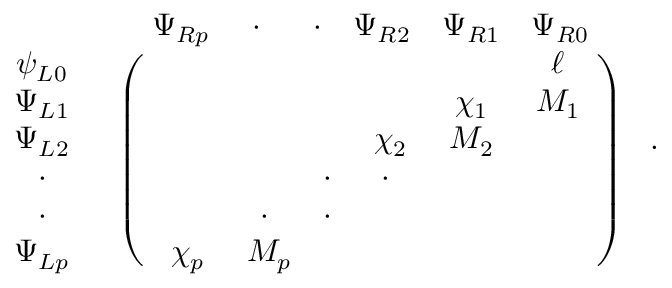Convert formula to latex. <formula><loc_0><loc_0><loc_500><loc_500>\begin{array} { c c & { { \begin{array} { c c c c c c } { { \Psi _ { R p } } } & { \cdot } & { \cdot } & { { \Psi _ { R 2 } } } & { { \Psi _ { R 1 } } } & { { \Psi _ { R 0 } } } \end{array} } } \\ { { \begin{array} { c } { { \psi _ { L 0 } } } \\ { { \Psi _ { L 1 } } } \\ { { \Psi _ { L 2 } } } \\ { \cdot } \\ { \cdot } \\ { { \Psi _ { L p } } } \end{array} } } & { { \left ( \begin{array} { c c c c c c & { \ell } & { { \chi _ { 1 } } } & { { M _ { 1 } } } & { { \chi _ { 2 } } } & { { M _ { 2 } } } & { \cdot } & { \cdot } & { \cdot } & { \cdot } \\ { { \chi _ { p } } } & { { M _ { p } } } \end{array} \right ) } } \end{array} .</formula> 